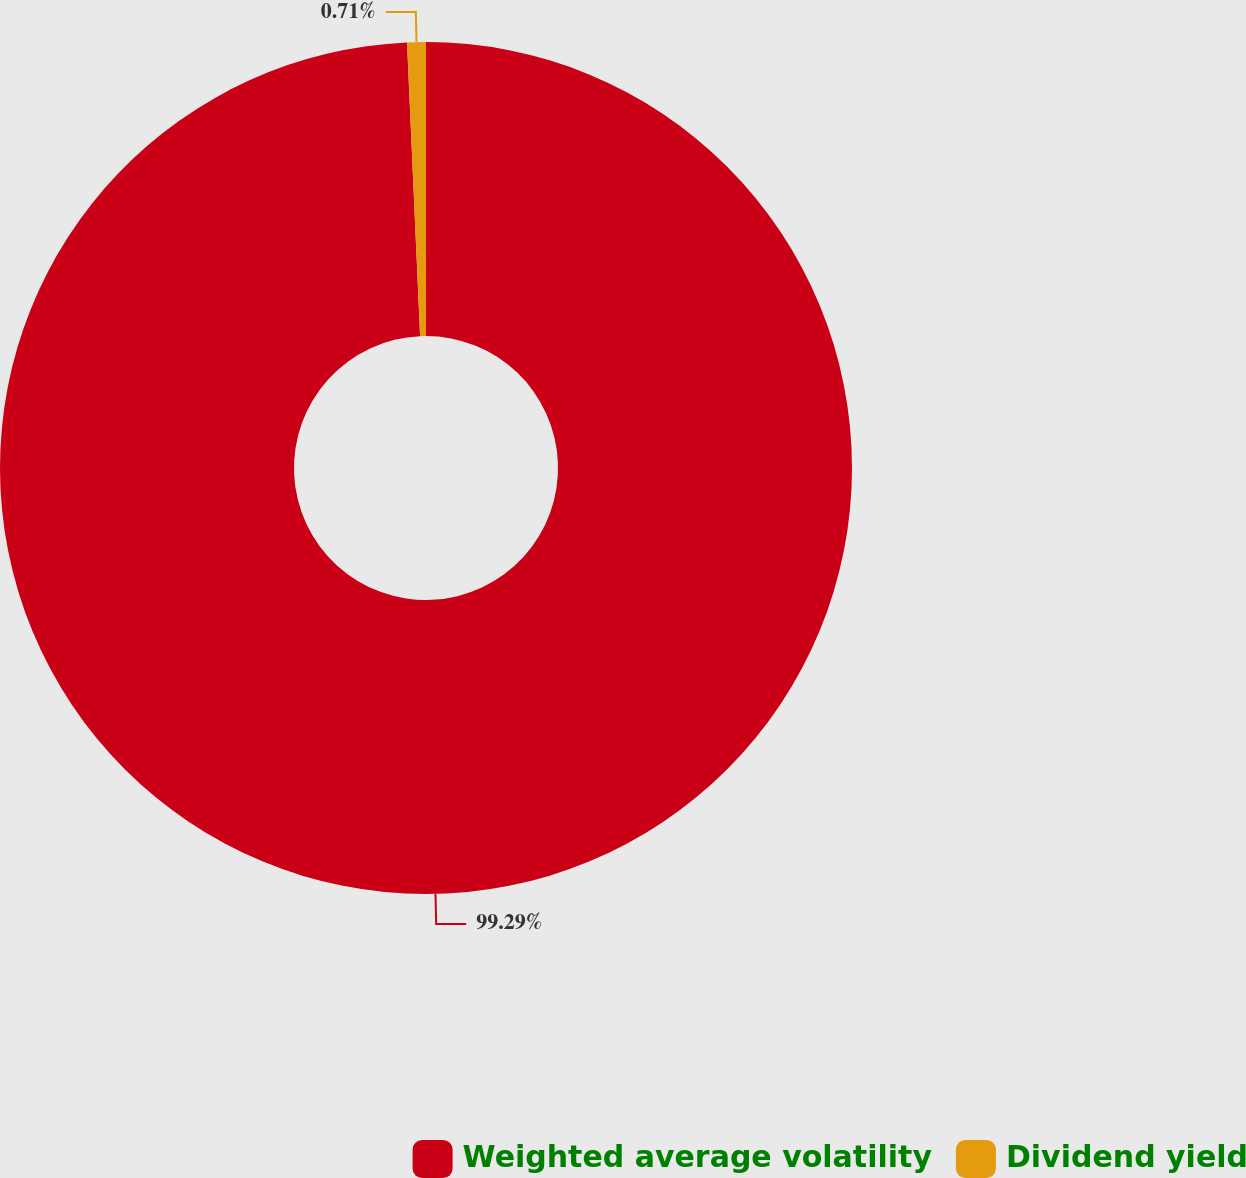Convert chart to OTSL. <chart><loc_0><loc_0><loc_500><loc_500><pie_chart><fcel>Weighted average volatility<fcel>Dividend yield<nl><fcel>99.29%<fcel>0.71%<nl></chart> 